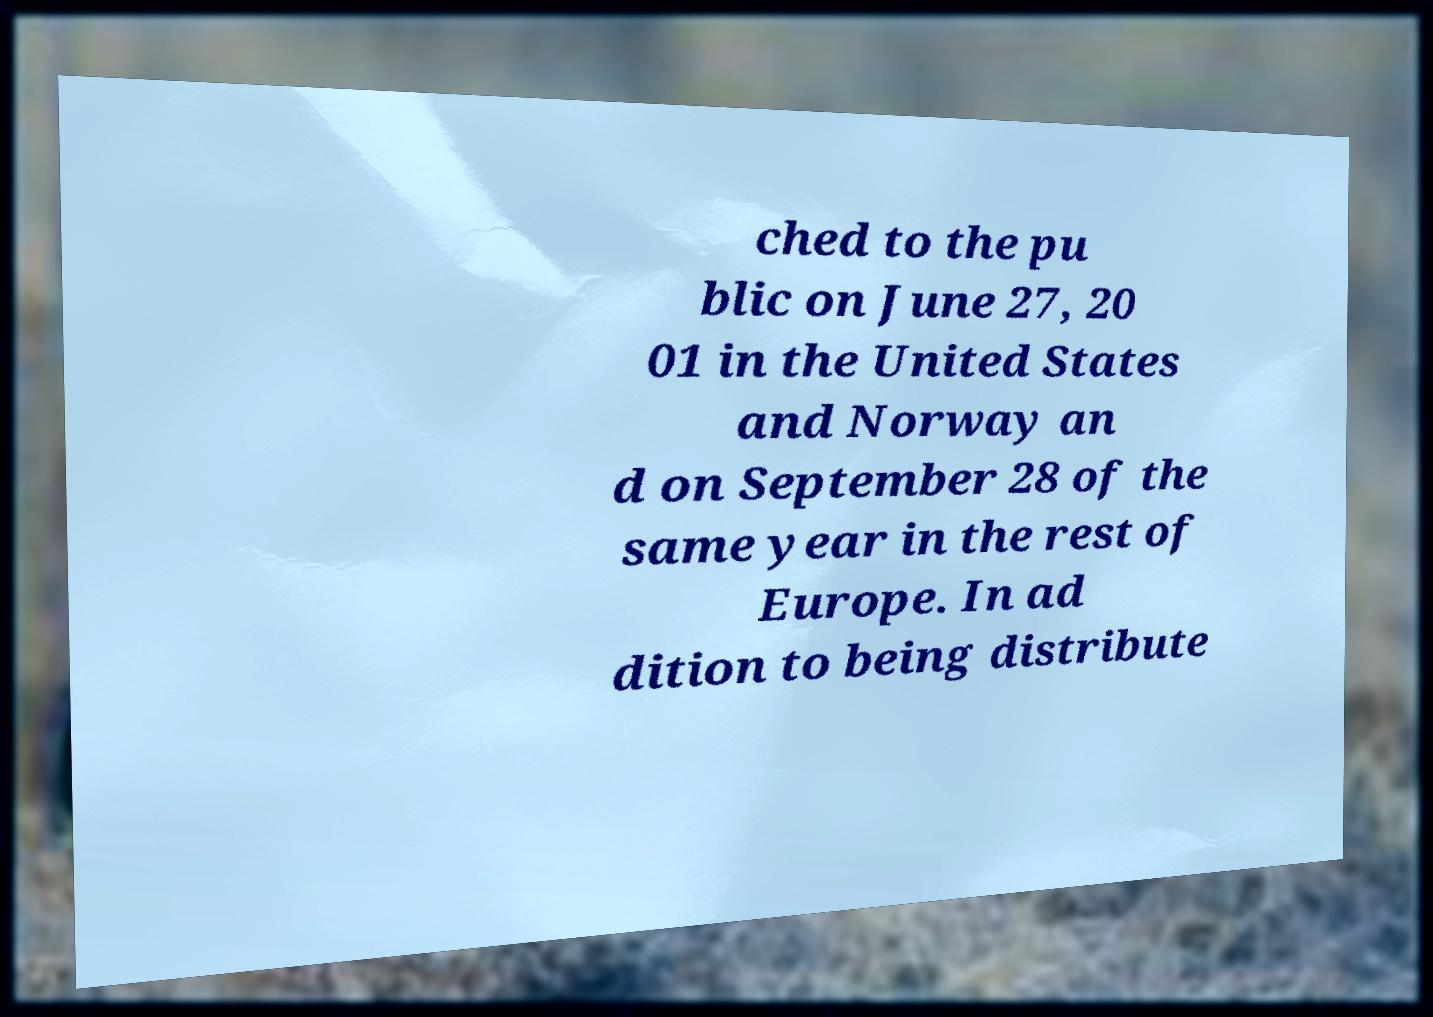Could you extract and type out the text from this image? ched to the pu blic on June 27, 20 01 in the United States and Norway an d on September 28 of the same year in the rest of Europe. In ad dition to being distribute 